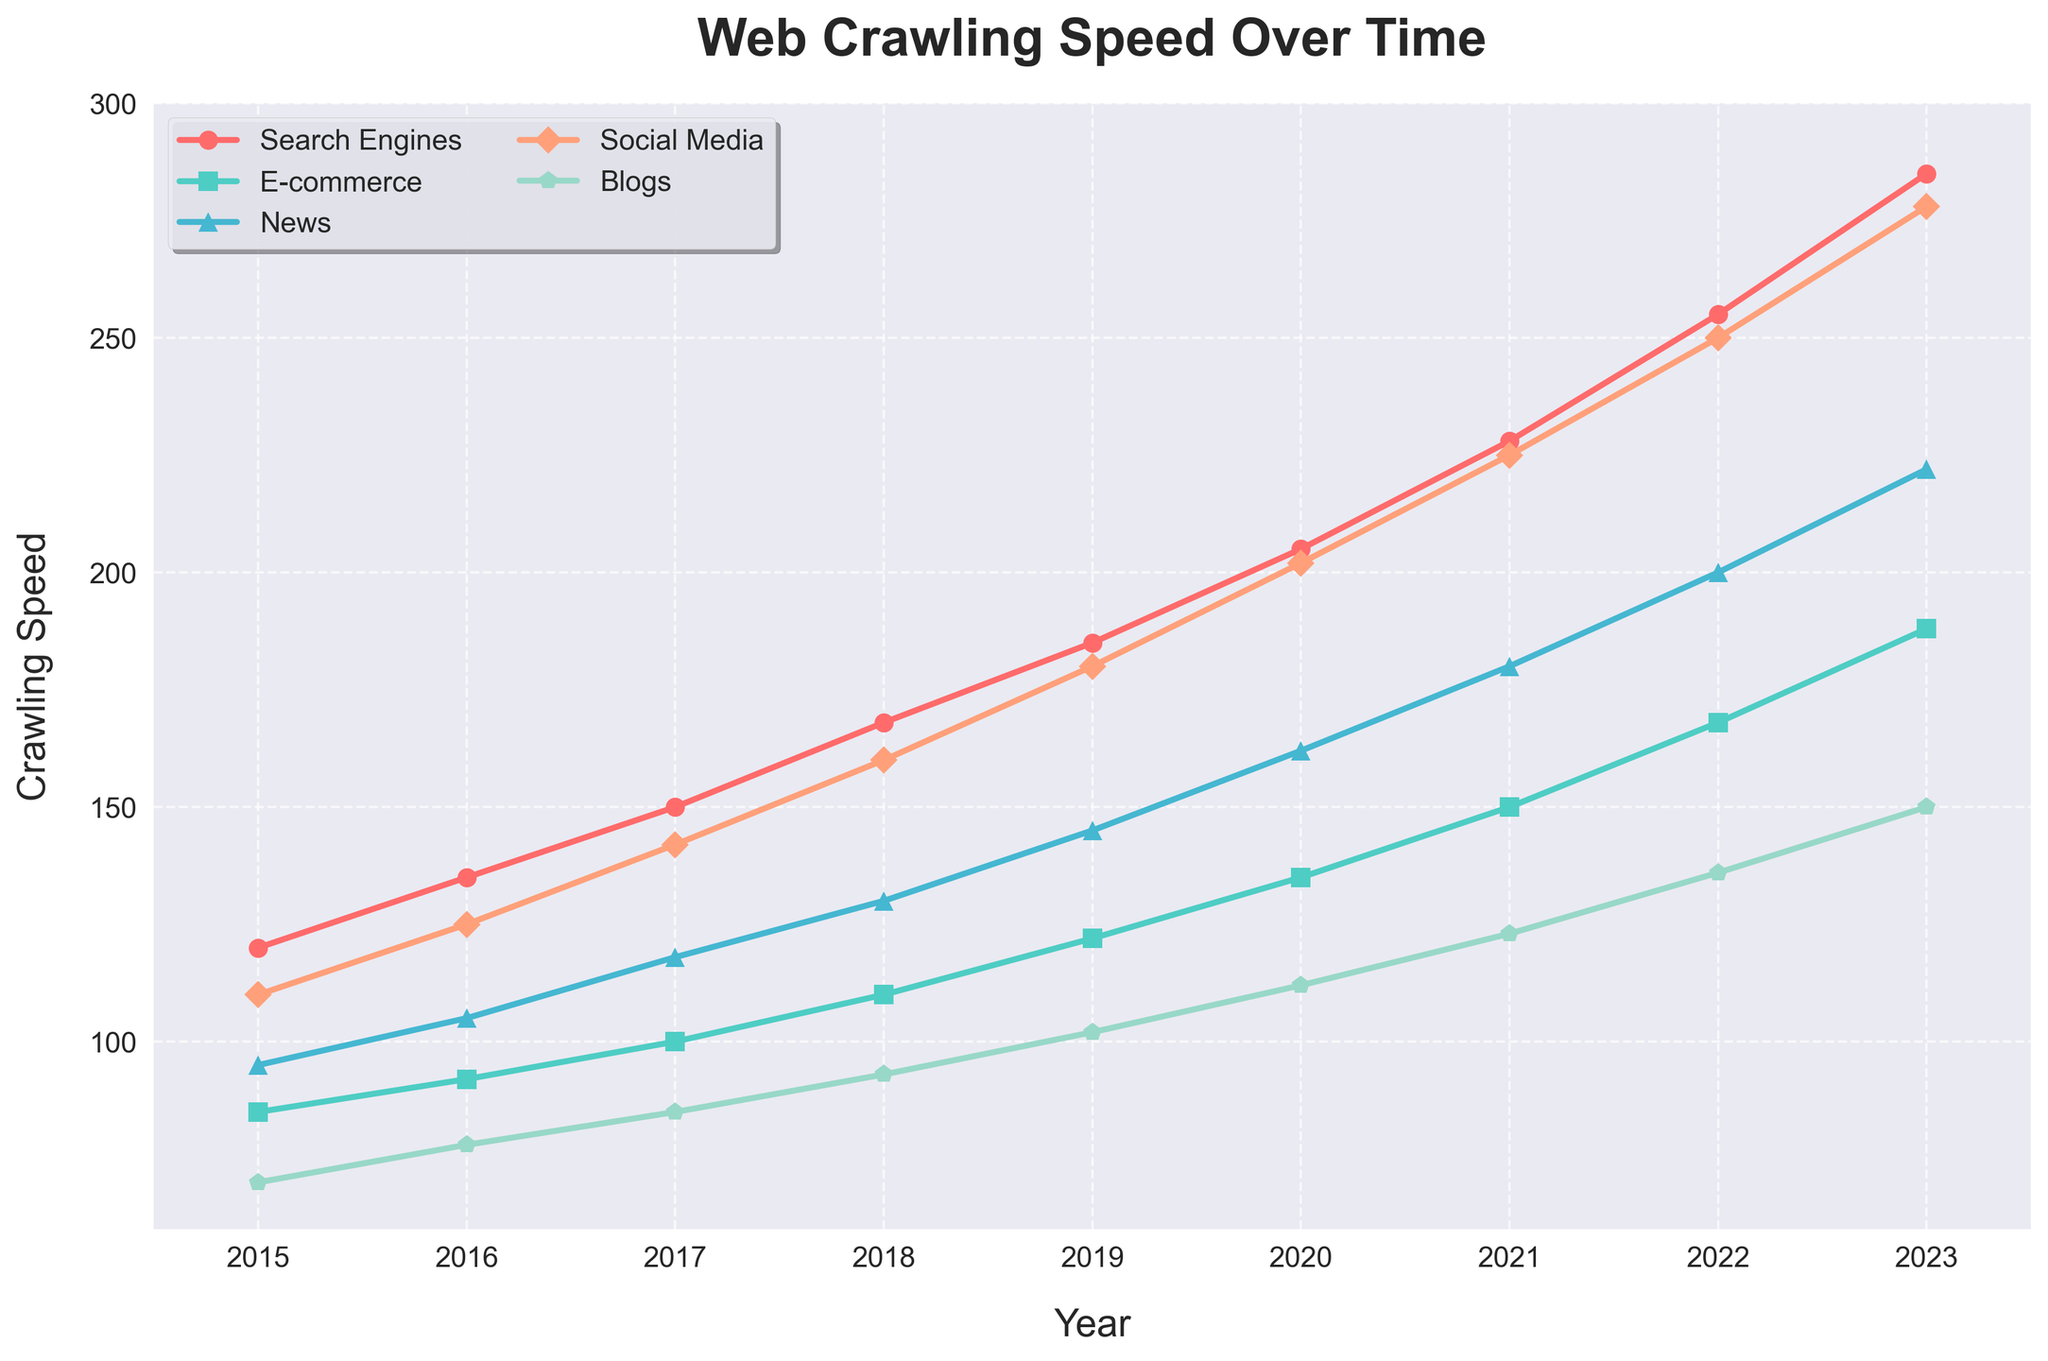What is the general trend of crawling speeds over time for all website categories? All website categories have steadily increasing crawling speeds over the years 2015 to 2023, indicating advancements in web crawling technologies.
Answer: Increasing Which website category had the highest crawling speed in 2023? In 2023, the line for the Social Media category is the highest on the y-axis, indicating the highest crawling speed among all the categories.
Answer: Social Media Between which two consecutive years did News websites experience the highest increase in crawling speed? By comparing the differences in the data points for the News category between consecutive years, the biggest increase is from 2016 (105) to 2017 (118), marking a jump of 13.
Answer: 2016 to 2017 How much did the crawling speed for Blogs increase from 2019 to 2023? In 2019, Blogs had a crawling speed of 102, and in 2023, it was 150. The increase is 150 - 102 = 48.
Answer: 48 In which year did E-commerce websites surpass a crawling speed of 150? By observing the E-commerce line, it exceeds the 150 mark in the year 2021.
Answer: 2021 Compare the crawling speed trends of Search Engines and Blogs between 2018 and 2023. From 2018 to 2023, the crawling speed for Search Engines increased from 168 to 285, while for Blogs it increased from 93 to 150. Both show an upward trend but Search Engines increased considerably more.
Answer: Both increased, but Search Engines more Which website category had the slowest crawling speed in 2015, and what was it? In 2015, Blogs had the lowest value on the y-axis compared to other categories, which was 70.
Answer: Blogs, 70 What is the average crawling speed for Social Media websites over the years shown? Sum the Social Media values from 2015 to 2023: 110 + 125 + 142 + 160 + 180 + 202 + 225 + 250 + 278 = 1672. There are 9 years, so the average is 1672/9 ≈ 185.78.
Answer: 185.78 Identify the year when News websites first showed a crawling speed above 200. Observing the News line, it crosses the 200 mark in the year 2022.
Answer: 2022 Which category showed the most consistent increase in crawling speed without any dips from 2015 to 2023? By carefully examining the line trends, all categories have consistent increases, but Search Engines show the smoothest, most consistent upward trend without any dips.
Answer: Search Engines 